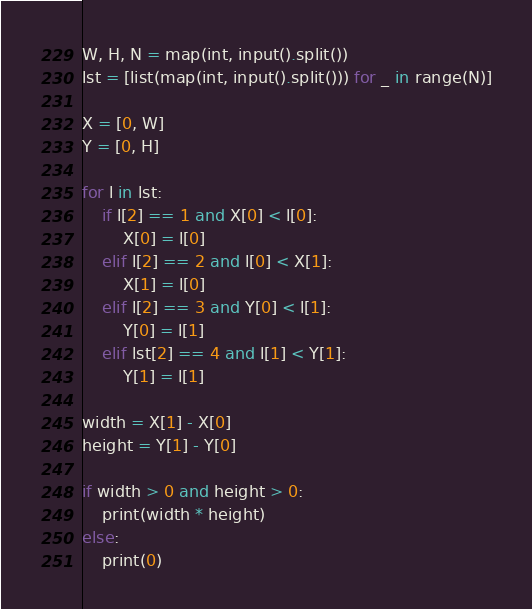<code> <loc_0><loc_0><loc_500><loc_500><_Python_>W, H, N = map(int, input().split())
lst = [list(map(int, input().split())) for _ in range(N)]

X = [0, W]
Y = [0, H]

for l in lst:
    if l[2] == 1 and X[0] < l[0]:
        X[0] = l[0]
    elif l[2] == 2 and l[0] < X[1]:
        X[1] = l[0]
    elif l[2] == 3 and Y[0] < l[1]:
        Y[0] = l[1]
    elif lst[2] == 4 and l[1] < Y[1]:
        Y[1] = l[1]

width = X[1] - X[0]
height = Y[1] - Y[0]

if width > 0 and height > 0:
    print(width * height)
else:
    print(0)</code> 